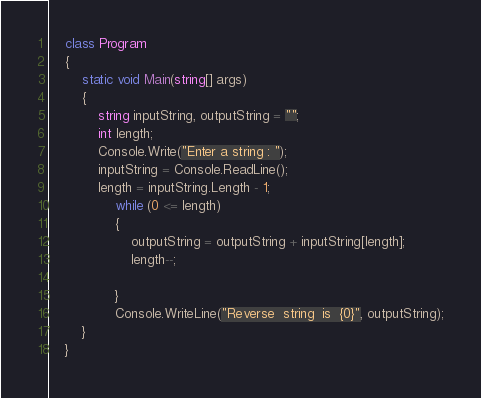<code> <loc_0><loc_0><loc_500><loc_500><_C#_>    class Program
    {
        static void Main(string[] args)
        {
            string inputString, outputString = "";
            int length;
            Console.Write("Enter a string : ");
            inputString = Console.ReadLine();
            length = inputString.Length - 1;
                while (0 <= length)
                {
                    outputString = outputString + inputString[length];
                    length--;

                }
                Console.WriteLine("Reverse  string  is  {0}", outputString);
        }
    }</code> 